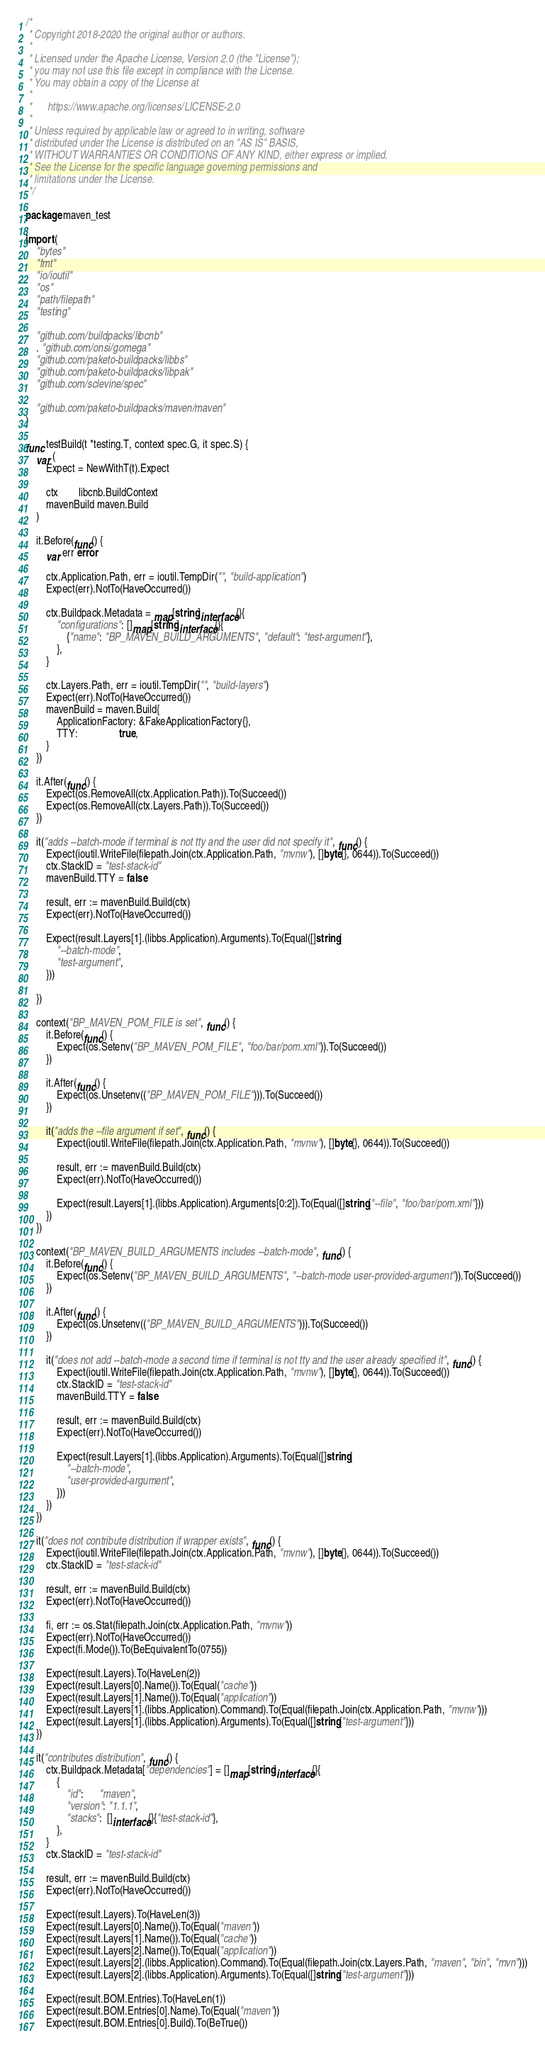Convert code to text. <code><loc_0><loc_0><loc_500><loc_500><_Go_>/*
 * Copyright 2018-2020 the original author or authors.
 *
 * Licensed under the Apache License, Version 2.0 (the "License");
 * you may not use this file except in compliance with the License.
 * You may obtain a copy of the License at
 *
 *      https://www.apache.org/licenses/LICENSE-2.0
 *
 * Unless required by applicable law or agreed to in writing, software
 * distributed under the License is distributed on an "AS IS" BASIS,
 * WITHOUT WARRANTIES OR CONDITIONS OF ANY KIND, either express or implied.
 * See the License for the specific language governing permissions and
 * limitations under the License.
 */

package maven_test

import (
	"bytes"
	"fmt"
	"io/ioutil"
	"os"
	"path/filepath"
	"testing"

	"github.com/buildpacks/libcnb"
	. "github.com/onsi/gomega"
	"github.com/paketo-buildpacks/libbs"
	"github.com/paketo-buildpacks/libpak"
	"github.com/sclevine/spec"

	"github.com/paketo-buildpacks/maven/maven"
)

func testBuild(t *testing.T, context spec.G, it spec.S) {
	var (
		Expect = NewWithT(t).Expect

		ctx        libcnb.BuildContext
		mavenBuild maven.Build
	)

	it.Before(func() {
		var err error

		ctx.Application.Path, err = ioutil.TempDir("", "build-application")
		Expect(err).NotTo(HaveOccurred())

		ctx.Buildpack.Metadata = map[string]interface{}{
			"configurations": []map[string]interface{}{
				{"name": "BP_MAVEN_BUILD_ARGUMENTS", "default": "test-argument"},
			},
		}

		ctx.Layers.Path, err = ioutil.TempDir("", "build-layers")
		Expect(err).NotTo(HaveOccurred())
		mavenBuild = maven.Build{
			ApplicationFactory: &FakeApplicationFactory{},
			TTY:                true,
		}
	})

	it.After(func() {
		Expect(os.RemoveAll(ctx.Application.Path)).To(Succeed())
		Expect(os.RemoveAll(ctx.Layers.Path)).To(Succeed())
	})

	it("adds --batch-mode if terminal is not tty and the user did not specify it", func() {
		Expect(ioutil.WriteFile(filepath.Join(ctx.Application.Path, "mvnw"), []byte{}, 0644)).To(Succeed())
		ctx.StackID = "test-stack-id"
		mavenBuild.TTY = false

		result, err := mavenBuild.Build(ctx)
		Expect(err).NotTo(HaveOccurred())

		Expect(result.Layers[1].(libbs.Application).Arguments).To(Equal([]string{
			"--batch-mode",
			"test-argument",
		}))

	})

	context("BP_MAVEN_POM_FILE is set", func() {
		it.Before(func() {
			Expect(os.Setenv("BP_MAVEN_POM_FILE", "foo/bar/pom.xml")).To(Succeed())
		})

		it.After(func() {
			Expect(os.Unsetenv(("BP_MAVEN_POM_FILE"))).To(Succeed())
		})

		it("adds the --file argument if set", func() {
			Expect(ioutil.WriteFile(filepath.Join(ctx.Application.Path, "mvnw"), []byte{}, 0644)).To(Succeed())

			result, err := mavenBuild.Build(ctx)
			Expect(err).NotTo(HaveOccurred())

			Expect(result.Layers[1].(libbs.Application).Arguments[0:2]).To(Equal([]string{"--file", "foo/bar/pom.xml"}))
		})
	})

	context("BP_MAVEN_BUILD_ARGUMENTS includes --batch-mode", func() {
		it.Before(func() {
			Expect(os.Setenv("BP_MAVEN_BUILD_ARGUMENTS", "--batch-mode user-provided-argument")).To(Succeed())
		})

		it.After(func() {
			Expect(os.Unsetenv(("BP_MAVEN_BUILD_ARGUMENTS"))).To(Succeed())
		})

		it("does not add --batch-mode a second time if terminal is not tty and the user already specified it", func() {
			Expect(ioutil.WriteFile(filepath.Join(ctx.Application.Path, "mvnw"), []byte{}, 0644)).To(Succeed())
			ctx.StackID = "test-stack-id"
			mavenBuild.TTY = false

			result, err := mavenBuild.Build(ctx)
			Expect(err).NotTo(HaveOccurred())

			Expect(result.Layers[1].(libbs.Application).Arguments).To(Equal([]string{
				"--batch-mode",
				"user-provided-argument",
			}))
		})
	})

	it("does not contribute distribution if wrapper exists", func() {
		Expect(ioutil.WriteFile(filepath.Join(ctx.Application.Path, "mvnw"), []byte{}, 0644)).To(Succeed())
		ctx.StackID = "test-stack-id"

		result, err := mavenBuild.Build(ctx)
		Expect(err).NotTo(HaveOccurred())

		fi, err := os.Stat(filepath.Join(ctx.Application.Path, "mvnw"))
		Expect(err).NotTo(HaveOccurred())
		Expect(fi.Mode()).To(BeEquivalentTo(0755))

		Expect(result.Layers).To(HaveLen(2))
		Expect(result.Layers[0].Name()).To(Equal("cache"))
		Expect(result.Layers[1].Name()).To(Equal("application"))
		Expect(result.Layers[1].(libbs.Application).Command).To(Equal(filepath.Join(ctx.Application.Path, "mvnw")))
		Expect(result.Layers[1].(libbs.Application).Arguments).To(Equal([]string{"test-argument"}))
	})

	it("contributes distribution", func() {
		ctx.Buildpack.Metadata["dependencies"] = []map[string]interface{}{
			{
				"id":      "maven",
				"version": "1.1.1",
				"stacks":  []interface{}{"test-stack-id"},
			},
		}
		ctx.StackID = "test-stack-id"

		result, err := mavenBuild.Build(ctx)
		Expect(err).NotTo(HaveOccurred())

		Expect(result.Layers).To(HaveLen(3))
		Expect(result.Layers[0].Name()).To(Equal("maven"))
		Expect(result.Layers[1].Name()).To(Equal("cache"))
		Expect(result.Layers[2].Name()).To(Equal("application"))
		Expect(result.Layers[2].(libbs.Application).Command).To(Equal(filepath.Join(ctx.Layers.Path, "maven", "bin", "mvn")))
		Expect(result.Layers[2].(libbs.Application).Arguments).To(Equal([]string{"test-argument"}))

		Expect(result.BOM.Entries).To(HaveLen(1))
		Expect(result.BOM.Entries[0].Name).To(Equal("maven"))
		Expect(result.BOM.Entries[0].Build).To(BeTrue())</code> 